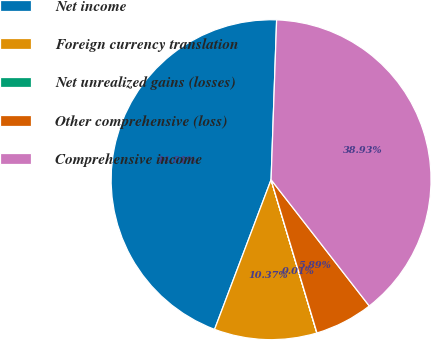Convert chart to OTSL. <chart><loc_0><loc_0><loc_500><loc_500><pie_chart><fcel>Net income<fcel>Foreign currency translation<fcel>Net unrealized gains (losses)<fcel>Other comprehensive (loss)<fcel>Comprehensive income<nl><fcel>44.81%<fcel>10.37%<fcel>0.01%<fcel>5.89%<fcel>38.93%<nl></chart> 